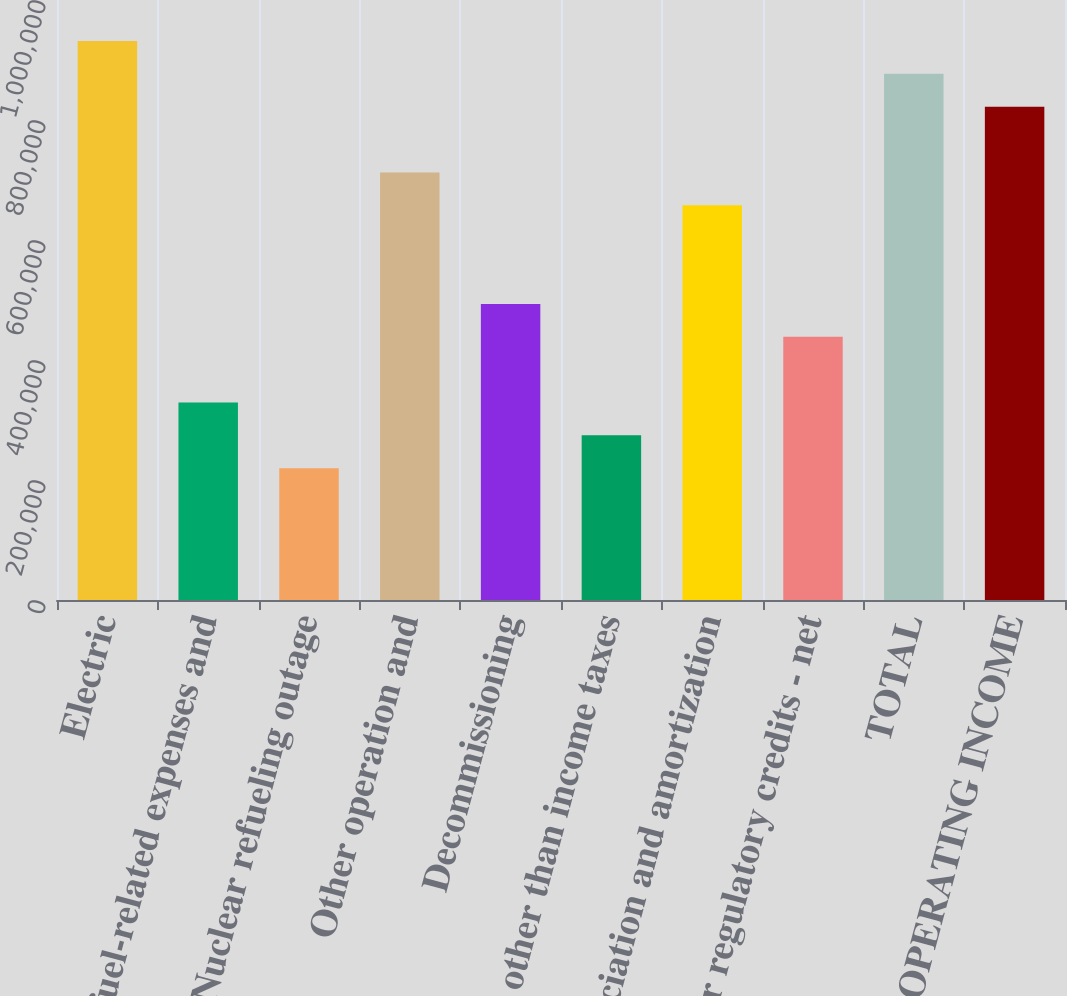Convert chart to OTSL. <chart><loc_0><loc_0><loc_500><loc_500><bar_chart><fcel>Electric<fcel>Fuel fuel-related expenses and<fcel>Nuclear refueling outage<fcel>Other operation and<fcel>Decommissioning<fcel>Taxes other than income taxes<fcel>Depreciation and amortization<fcel>Other regulatory credits - net<fcel>TOTAL<fcel>OPERATING INCOME<nl><fcel>931706<fcel>329197<fcel>219650<fcel>712612<fcel>493518<fcel>274424<fcel>657838<fcel>438744<fcel>876932<fcel>822158<nl></chart> 